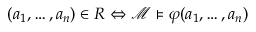<formula> <loc_0><loc_0><loc_500><loc_500>( a _ { 1 } , \dots , a _ { n } ) \in R \Leftrightarrow { \mathcal { M } } \vDash \varphi ( a _ { 1 } , \dots , a _ { n } )</formula> 